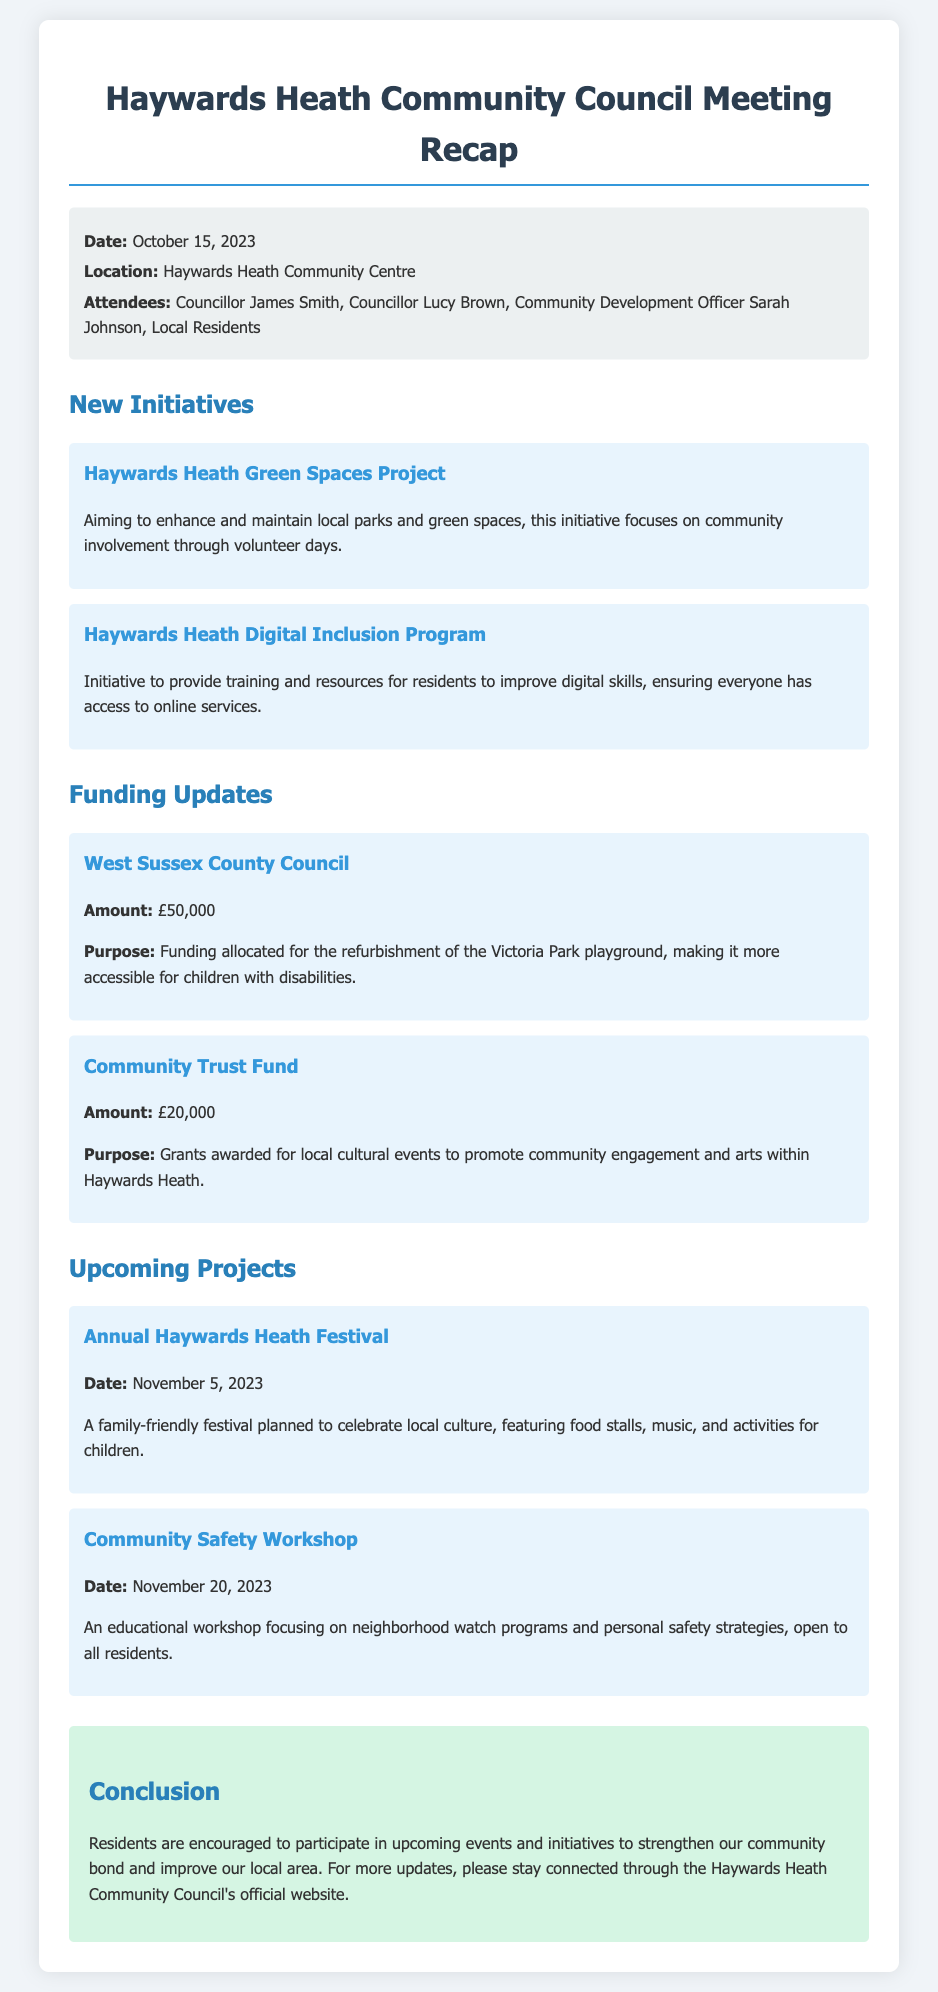What is the date of the meeting? The date of the meeting is specifically mentioned in the document, which is October 15, 2023.
Answer: October 15, 2023 What amount was allocated by West Sussex County Council? The document states that West Sussex County Council allocated £50,000 for a specific purpose.
Answer: £50,000 What is the purpose of the funding from the Community Trust Fund? The purpose is detailed in the information provided which states that it's for local cultural events to promote community engagement and arts.
Answer: Grants for local cultural events What is the name of the initiative focused on enhancing local parks? The initiative aimed at enhancing and maintaining local parks is clearly titled in the document as the Haywards Heath Green Spaces Project.
Answer: Haywards Heath Green Spaces Project What is the date of the Annual Haywards Heath Festival? The festival date is provided in the section regarding upcoming projects, specifically on November 5, 2023.
Answer: November 5, 2023 What is a main theme of the upcoming Community Safety Workshop? The document provides insight into the workshop’s focus, identifying it as an educational workshop on neighborhood watch programs and personal safety strategies.
Answer: Neighborhood watch and personal safety Who is one of the attendees listed in the meeting? The list of attendees contains names, one of which is Councillor James Smith.
Answer: Councillor James Smith What initiative aims to improve digital skills for residents? The initiative focused on enhancing digital skills for community members is explicitly mentioned as the Haywards Heath Digital Inclusion Program.
Answer: Haywards Heath Digital Inclusion Program What type of event is the Annual Haywards Heath Festival? The document describes the festival as a family-friendly festival celebrating local culture.
Answer: Family-friendly cultural festival 